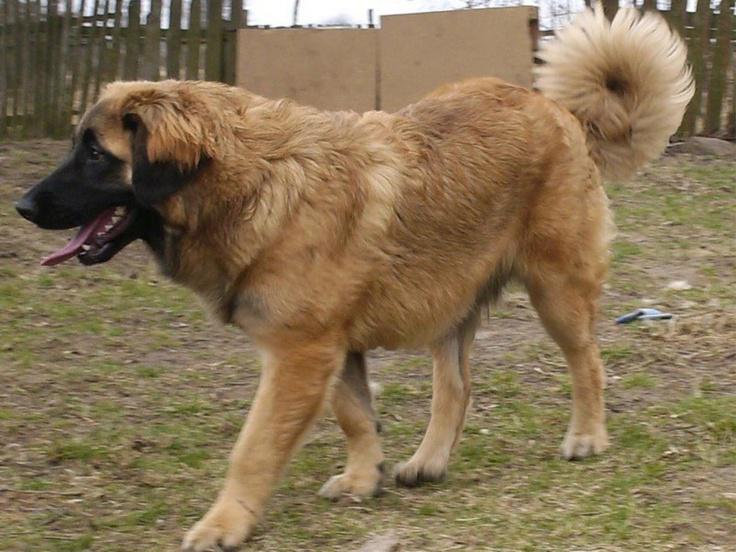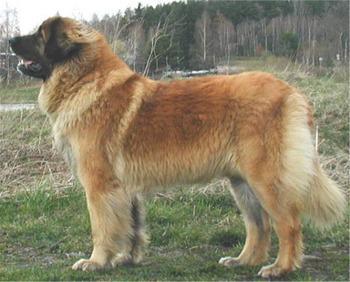The first image is the image on the left, the second image is the image on the right. For the images displayed, is the sentence "Each image contains exactly one dog, which is standing in profile." factually correct? Answer yes or no. Yes. The first image is the image on the left, the second image is the image on the right. Given the left and right images, does the statement "There are at least three dogs  outside." hold true? Answer yes or no. No. 